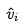Convert formula to latex. <formula><loc_0><loc_0><loc_500><loc_500>\hat { v } _ { i }</formula> 